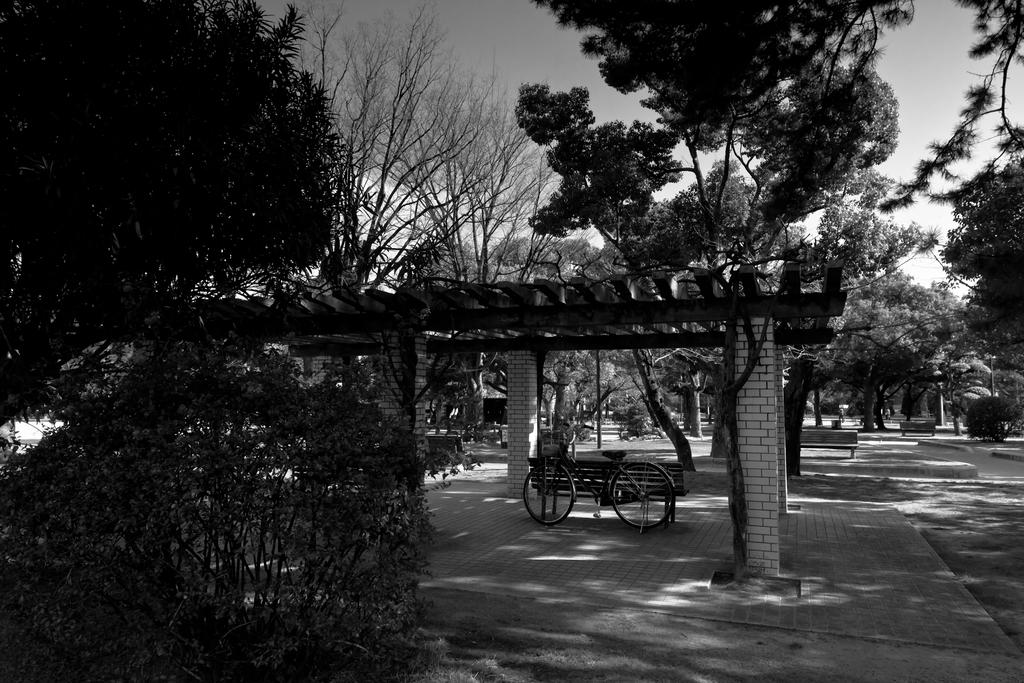What type of vehicle is in the image? There is a bicycle in the image. What type of seating is present in the image? There is a bench in the image. What architectural feature can be seen in the image? There is a pillar in the image. What type of plant is in the image? There is a plant in the image. What type of vegetation is in the image? There are trees in the image. What type of path is in the image? There is a footpath in the image. What part of the natural environment is visible in the image? The sky is visible in the image. What type of jam is spread on the roof in the image? There is no jam or roof present in the image. What angle is the bicycle leaning at in the image? The bicycle is not leaning at any angle in the image; it appears to be stationary. 